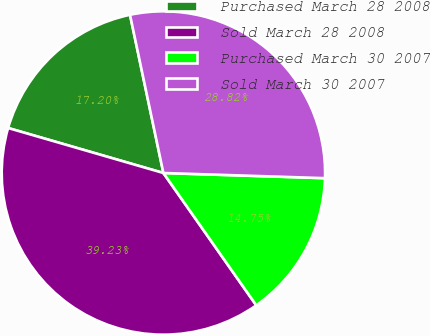Convert chart to OTSL. <chart><loc_0><loc_0><loc_500><loc_500><pie_chart><fcel>Purchased March 28 2008<fcel>Sold March 28 2008<fcel>Purchased March 30 2007<fcel>Sold March 30 2007<nl><fcel>17.2%<fcel>39.23%<fcel>14.75%<fcel>28.82%<nl></chart> 